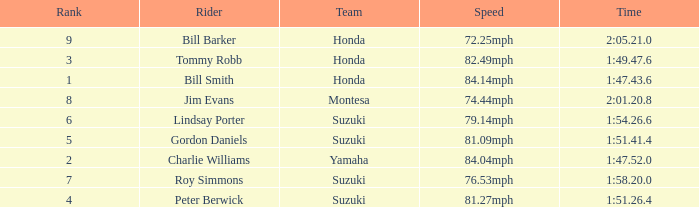Which rider had a time of 1:54.26.6? Lindsay Porter. 